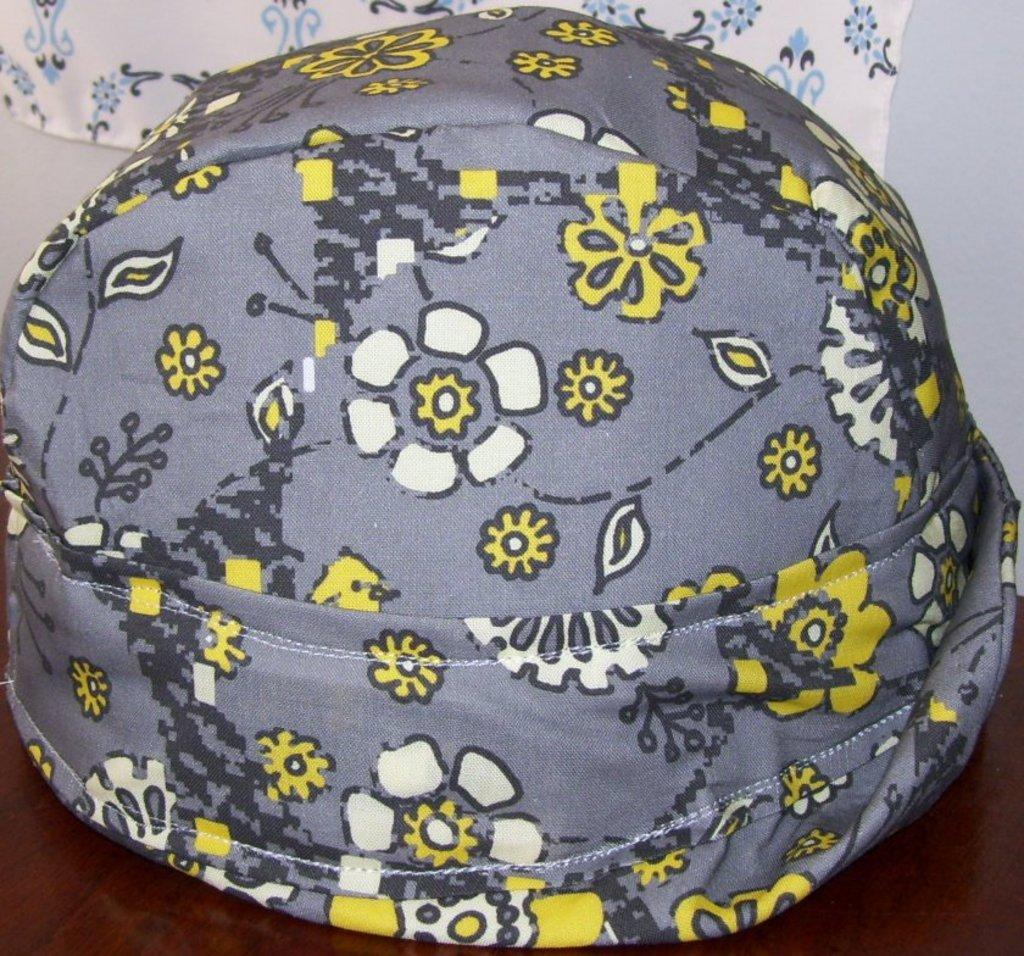What object is placed on the table in the image? There is a cap placed on a table in the image. What can be seen in the background of the image? There is a wall and a cloth in the background of the image. What type of icicle can be seen hanging from the wall in the image? There is no icicle present in the image; it is an indoor setting with a wall and a cloth in the background. 